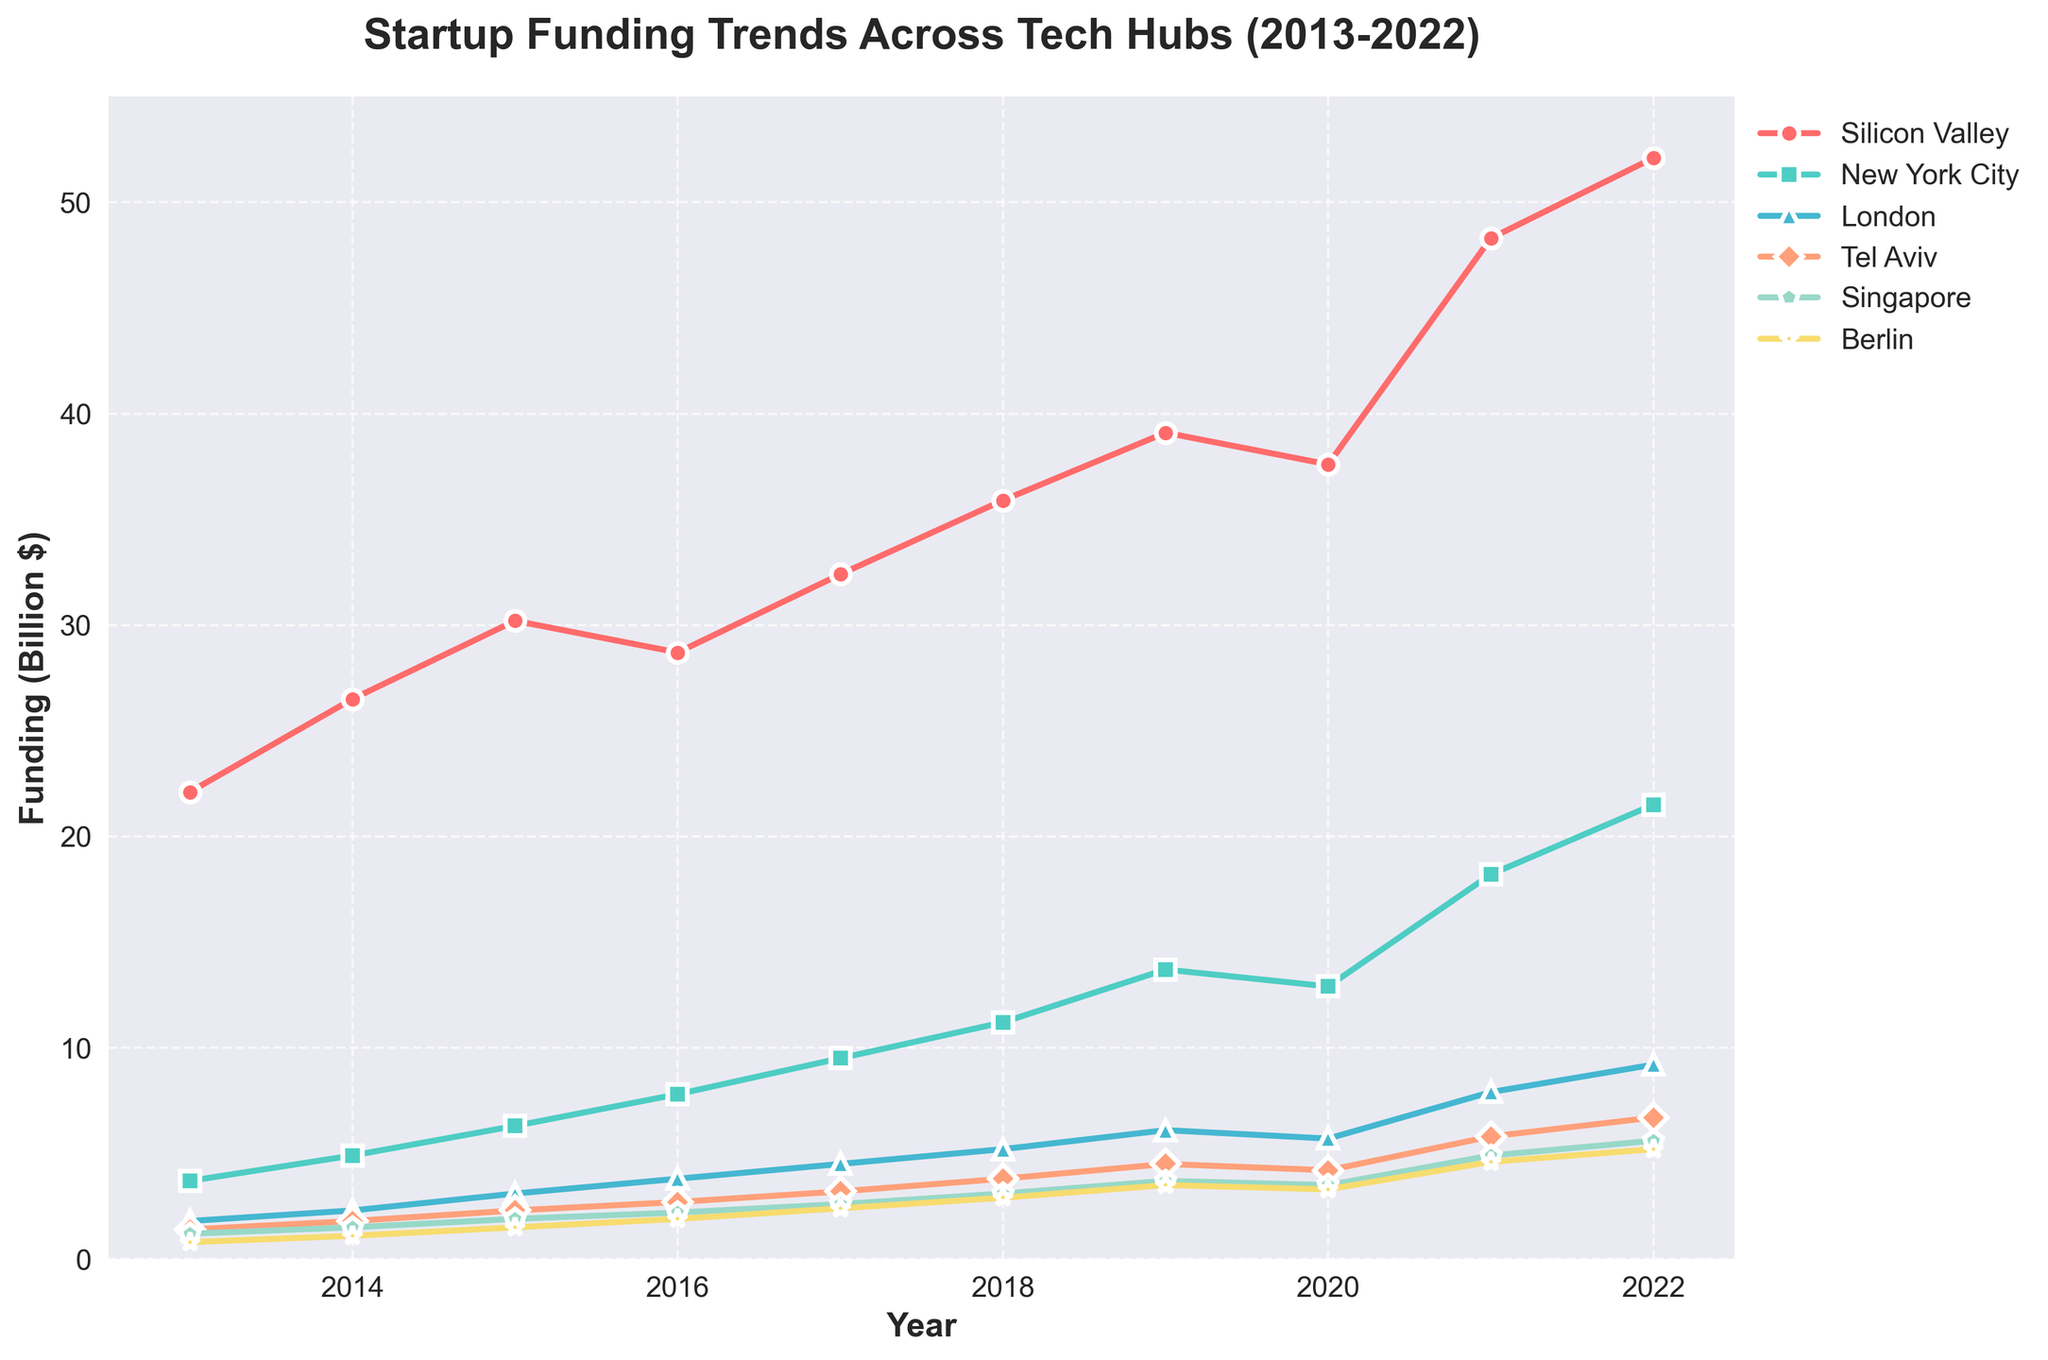What’s the overall funding trend for Silicon Valley from 2013 to 2022? To determine the trend for Silicon Valley, observe the funding amounts year by year. Starting from $22.1 billion in 2013, the funding increases steadily to $52.1 billion by 2022. This indicates a positive growth trend over the decade.
Answer: Positive growth trend Which tech hub saw the highest growth in funding from 2013 to 2022? To find the tech hub with the highest growth, calculate the difference in funding from 2013 to 2022 for each hub. Silicon Valley increased from $22.1 to $52.1 (increase of $30 billion), New York City from $3.7 to $21.5 (increase of $17.8 billion), London from $1.8 to $9.2 (increase of $7.4 billion), Tel Aviv from $1.4 to $6.7 (increase of $5.3 billion), Singapore from $1.2 to $5.6 (increase of $4.4 billion), and Berlin from $0.8 to $5.2 (increase of $4.4 billion). Silicon Valley shows the highest growth.
Answer: Silicon Valley How did the funding for New York City compare to London’s funding in 2021? Check the funding amounts for New York City and London in 2021. New York City’s funding was $18.2 billion, while London’s funding was $7.9 billion. New York City’s funding is significantly higher.
Answer: New York City’s funding is higher What is the total funding for all tech hubs in 2020? Sum the funding amounts for all six tech hubs in 2020: Silicon Valley ($37.6 billion), New York City ($12.9 billion), London ($5.7 billion), Tel Aviv ($4.2 billion), Singapore ($3.5 billion), and Berlin ($3.3 billion). The total is $67.2 billion.
Answer: $67.2 billion When did Tel Aviv’s funding first exceed $4 billion? Look at the funding amounts for Tel Aviv over the years. Tel Aviv’s funding first exceeded $4 billion in 2019, when it reached $4.5 billion.
Answer: 2019 Which tech hub had the least amount of funding in 2013 and what was the amount? In 2013, compare the funding amounts for all the tech hubs. Berlin had the least funding with $0.8 billion.
Answer: Berlin with $0.8 billion Between which consecutive years did Singapore witness the highest growth in funding? Calculate the year-to-year funding increase for Singapore:
- 2013-2014: $1.5B - $1.2B = $0.3B 
- 2014-2015: $1.9B - $1.5B = $0.4B 
- 2015-2016: $2.2B - $1.9B = $0.3B 
- 2016-2017: $2.6B - $2.2B = $0.4B 
- 2017-2018: $3.1B - $2.6B = $0.5B 
- 2018-2019: $3.7B - $3.1B = $0.6B 
- 2019-2020: $3.5B - $3.7B = -$0.2B 
- 2020-2021: $4.9B - $3.5B = $1.4B 
- 2021-2022: $5.6B - $4.9B = $0.7B
The highest growth occurred between 2020 and 2021.
Answer: 2020-2021 By how much did Berlin's funding increase from 2015 to 2020? Compare the funding for Berlin in 2015 ($1.5 billion) and 2020 ($3.3 billion). The increase is $3.3 billion - $1.5 billion = $1.8 billion.
Answer: $1.8 billion Which year saw the greatest funding for London? Check the funding values for London across all years. The greatest funding amount for London is $9.2 billion in 2022.
Answer: 2022 